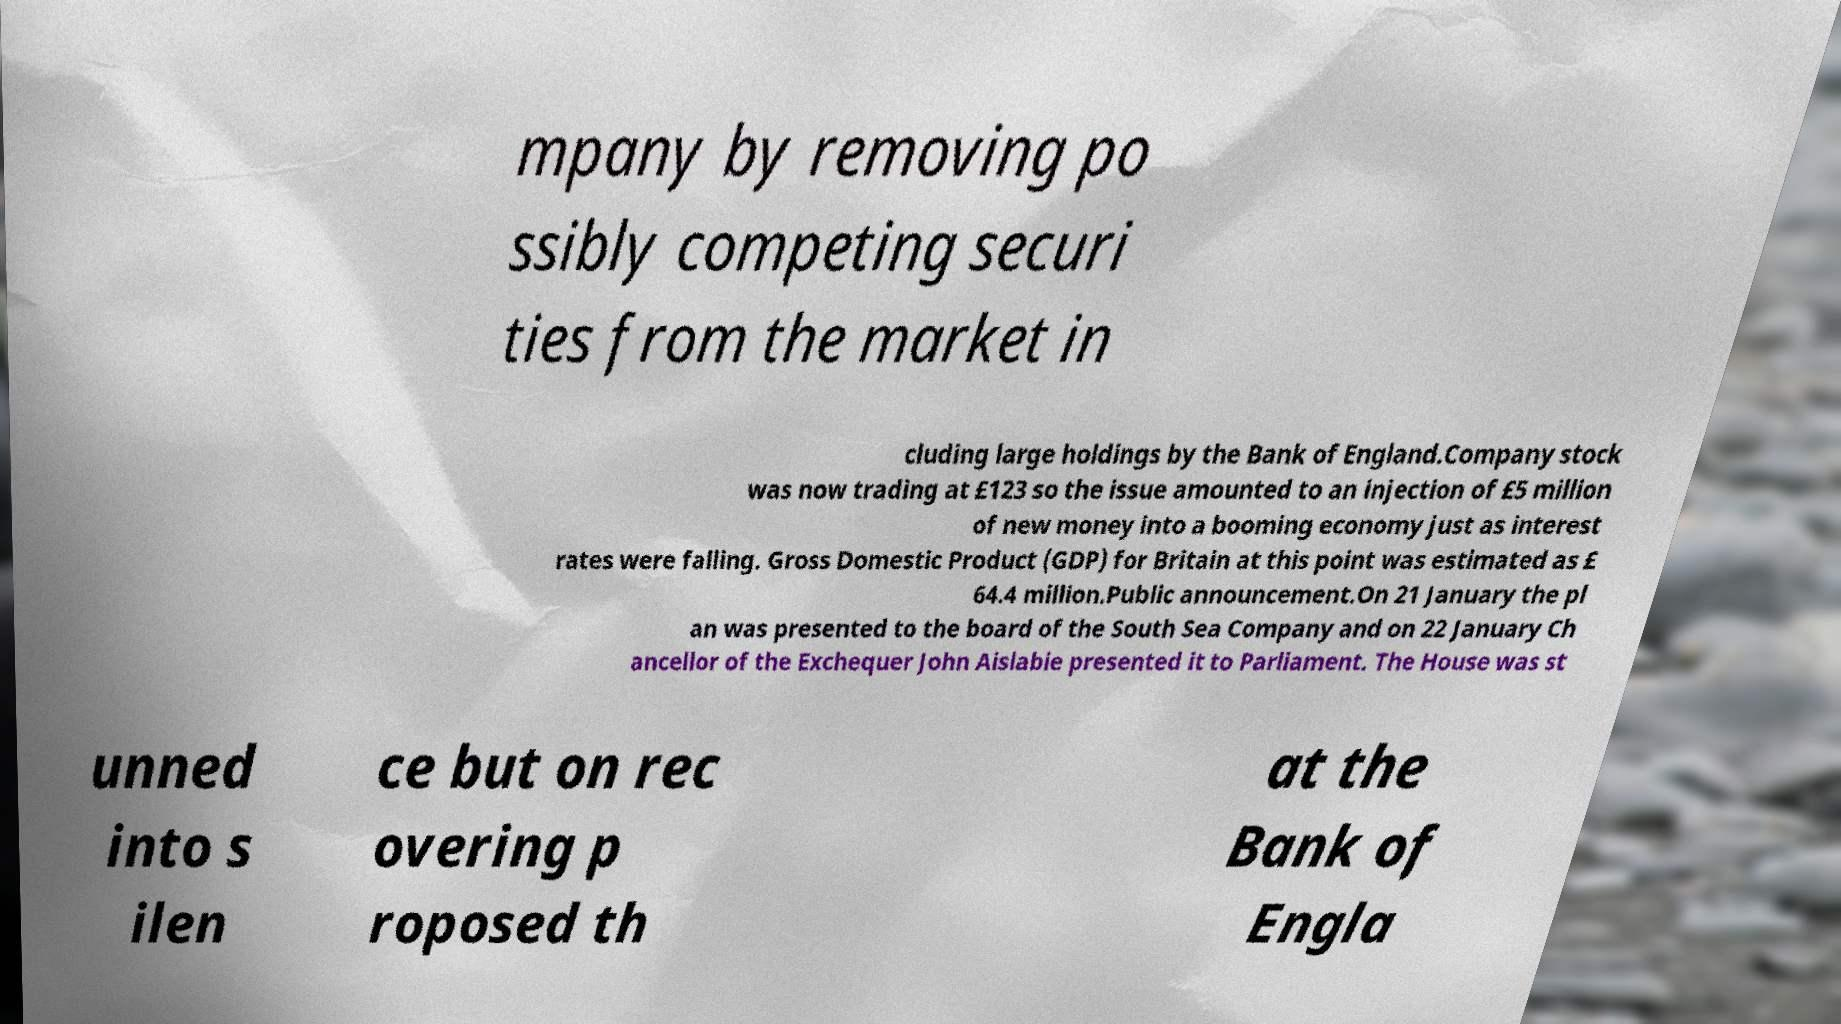Could you assist in decoding the text presented in this image and type it out clearly? mpany by removing po ssibly competing securi ties from the market in cluding large holdings by the Bank of England.Company stock was now trading at £123 so the issue amounted to an injection of £5 million of new money into a booming economy just as interest rates were falling. Gross Domestic Product (GDP) for Britain at this point was estimated as £ 64.4 million.Public announcement.On 21 January the pl an was presented to the board of the South Sea Company and on 22 January Ch ancellor of the Exchequer John Aislabie presented it to Parliament. The House was st unned into s ilen ce but on rec overing p roposed th at the Bank of Engla 